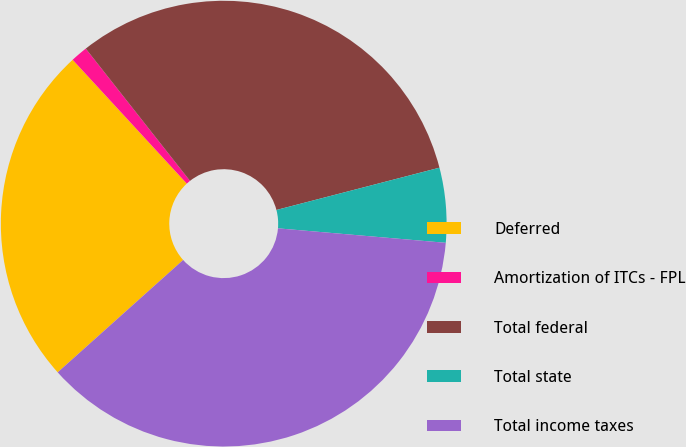Convert chart to OTSL. <chart><loc_0><loc_0><loc_500><loc_500><pie_chart><fcel>Deferred<fcel>Amortization of ITCs - FPL<fcel>Total federal<fcel>Total state<fcel>Total income taxes<nl><fcel>24.77%<fcel>1.23%<fcel>31.58%<fcel>5.41%<fcel>37.0%<nl></chart> 